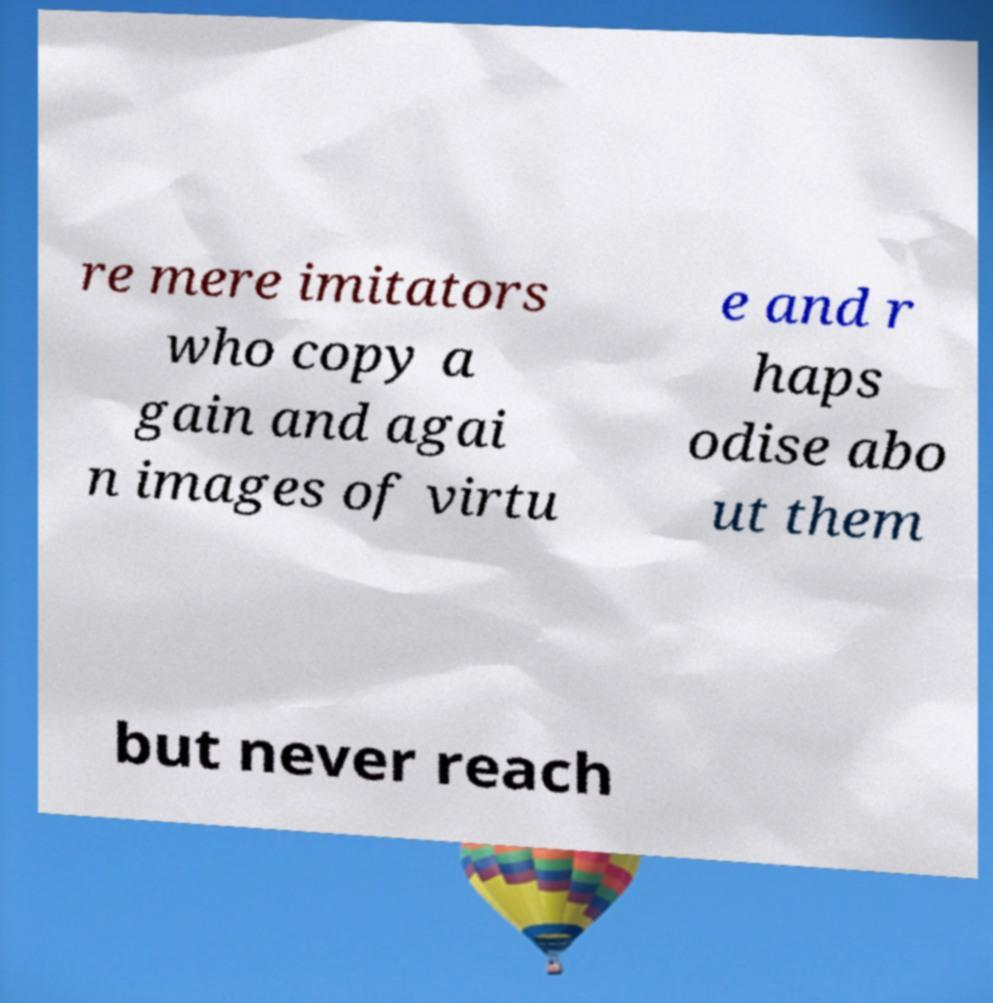I need the written content from this picture converted into text. Can you do that? re mere imitators who copy a gain and agai n images of virtu e and r haps odise abo ut them but never reach 